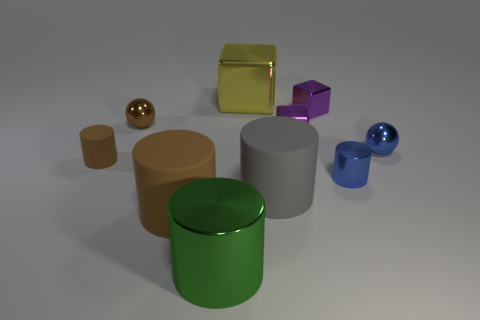Which shapes in the image are not cylinders? In the image, the objects that are not cylinders include the golden sphere, the golden cube, the purple cube, and the two blue spheres. The remaining objects, consisting of a brown cylinder, a green cylinder, and a large gray cylinder, are the only cylindrical shapes present.  Are there any patterns or consistency in the placement of these objects? The objects seem to be arranged without a specific pattern in terms of color or shape. However, they are thoughtfully spaced, suggesting an intentional composition with attention to balance and spacing, possibly to highlight their forms and reflective properties. 